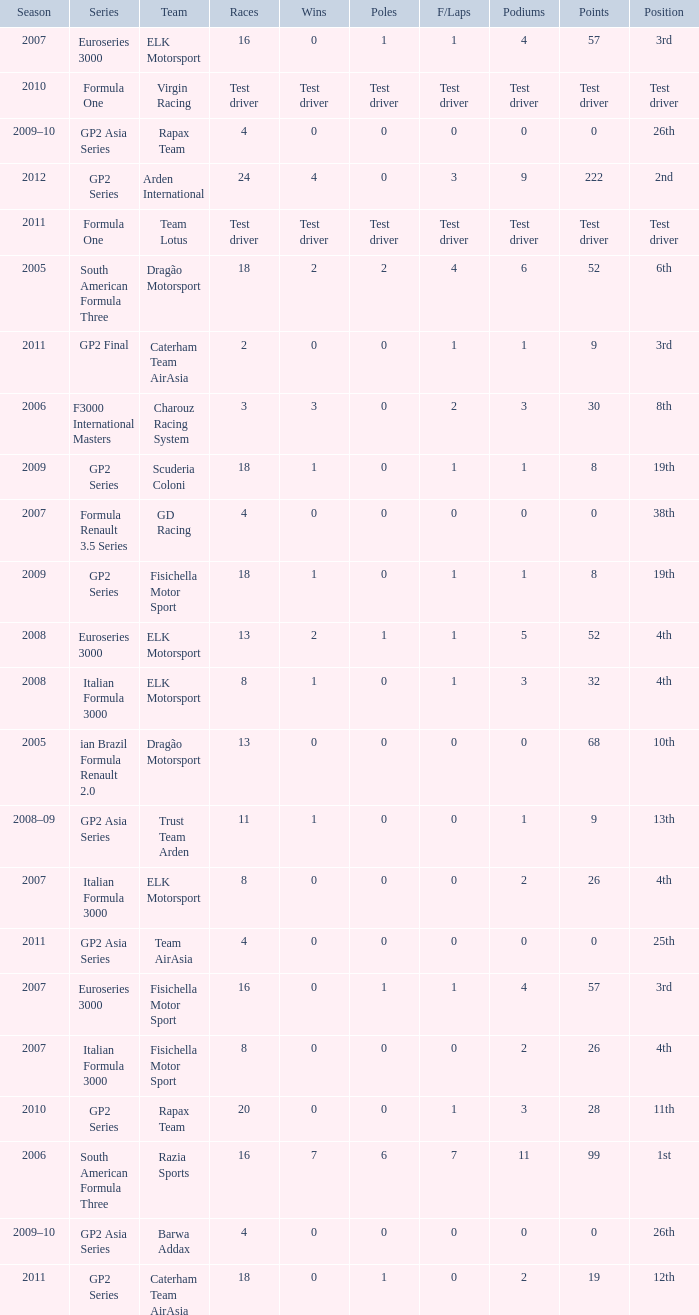How many races did he do in the year he had 8 points? 18, 18. 